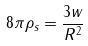Convert formula to latex. <formula><loc_0><loc_0><loc_500><loc_500>8 \pi \rho _ { s } = \frac { 3 w } { R ^ { 2 } }</formula> 